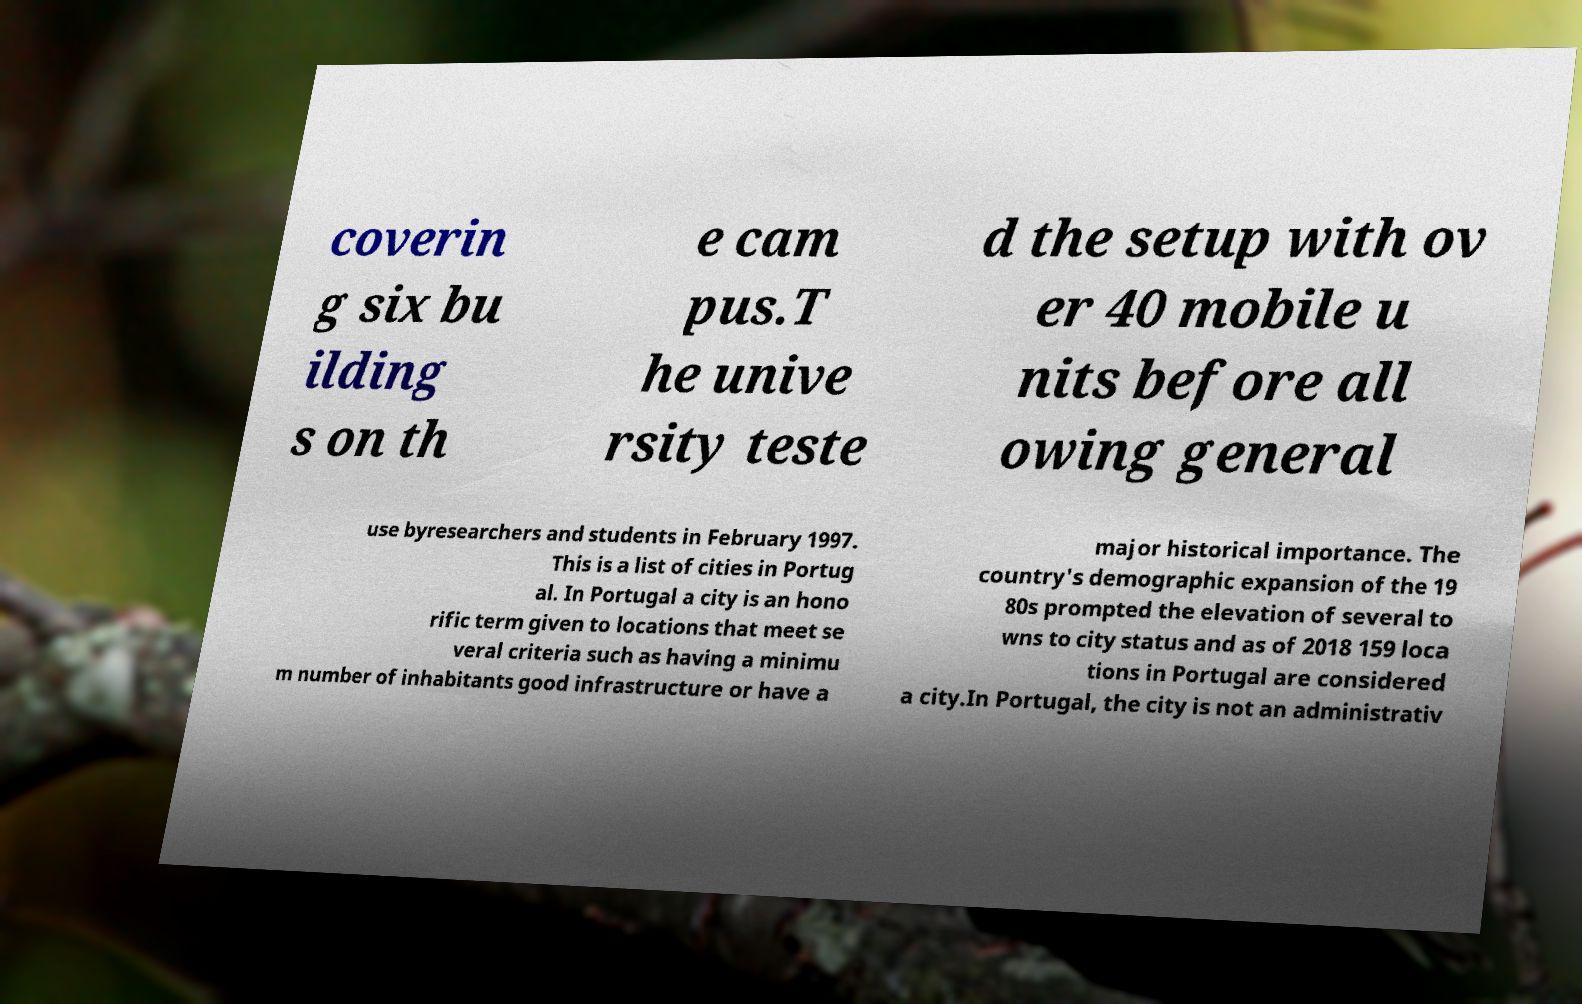Could you extract and type out the text from this image? coverin g six bu ilding s on th e cam pus.T he unive rsity teste d the setup with ov er 40 mobile u nits before all owing general use byresearchers and students in February 1997. This is a list of cities in Portug al. In Portugal a city is an hono rific term given to locations that meet se veral criteria such as having a minimu m number of inhabitants good infrastructure or have a major historical importance. The country's demographic expansion of the 19 80s prompted the elevation of several to wns to city status and as of 2018 159 loca tions in Portugal are considered a city.In Portugal, the city is not an administrativ 